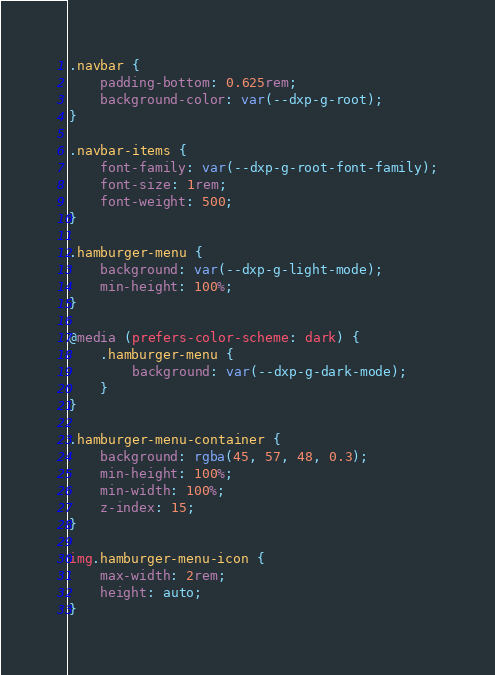Convert code to text. <code><loc_0><loc_0><loc_500><loc_500><_CSS_>.navbar {
    padding-bottom: 0.625rem;
    background-color: var(--dxp-g-root);
}

.navbar-items {
    font-family: var(--dxp-g-root-font-family);
    font-size: 1rem;
    font-weight: 500;
}

.hamburger-menu {
    background: var(--dxp-g-light-mode);
    min-height: 100%;
}

@media (prefers-color-scheme: dark) {
    .hamburger-menu {
        background: var(--dxp-g-dark-mode);
    }
}

.hamburger-menu-container {
    background: rgba(45, 57, 48, 0.3);
    min-height: 100%;
    min-width: 100%;
    z-index: 15;
}

img.hamburger-menu-icon {
    max-width: 2rem;
    height: auto;
}
</code> 